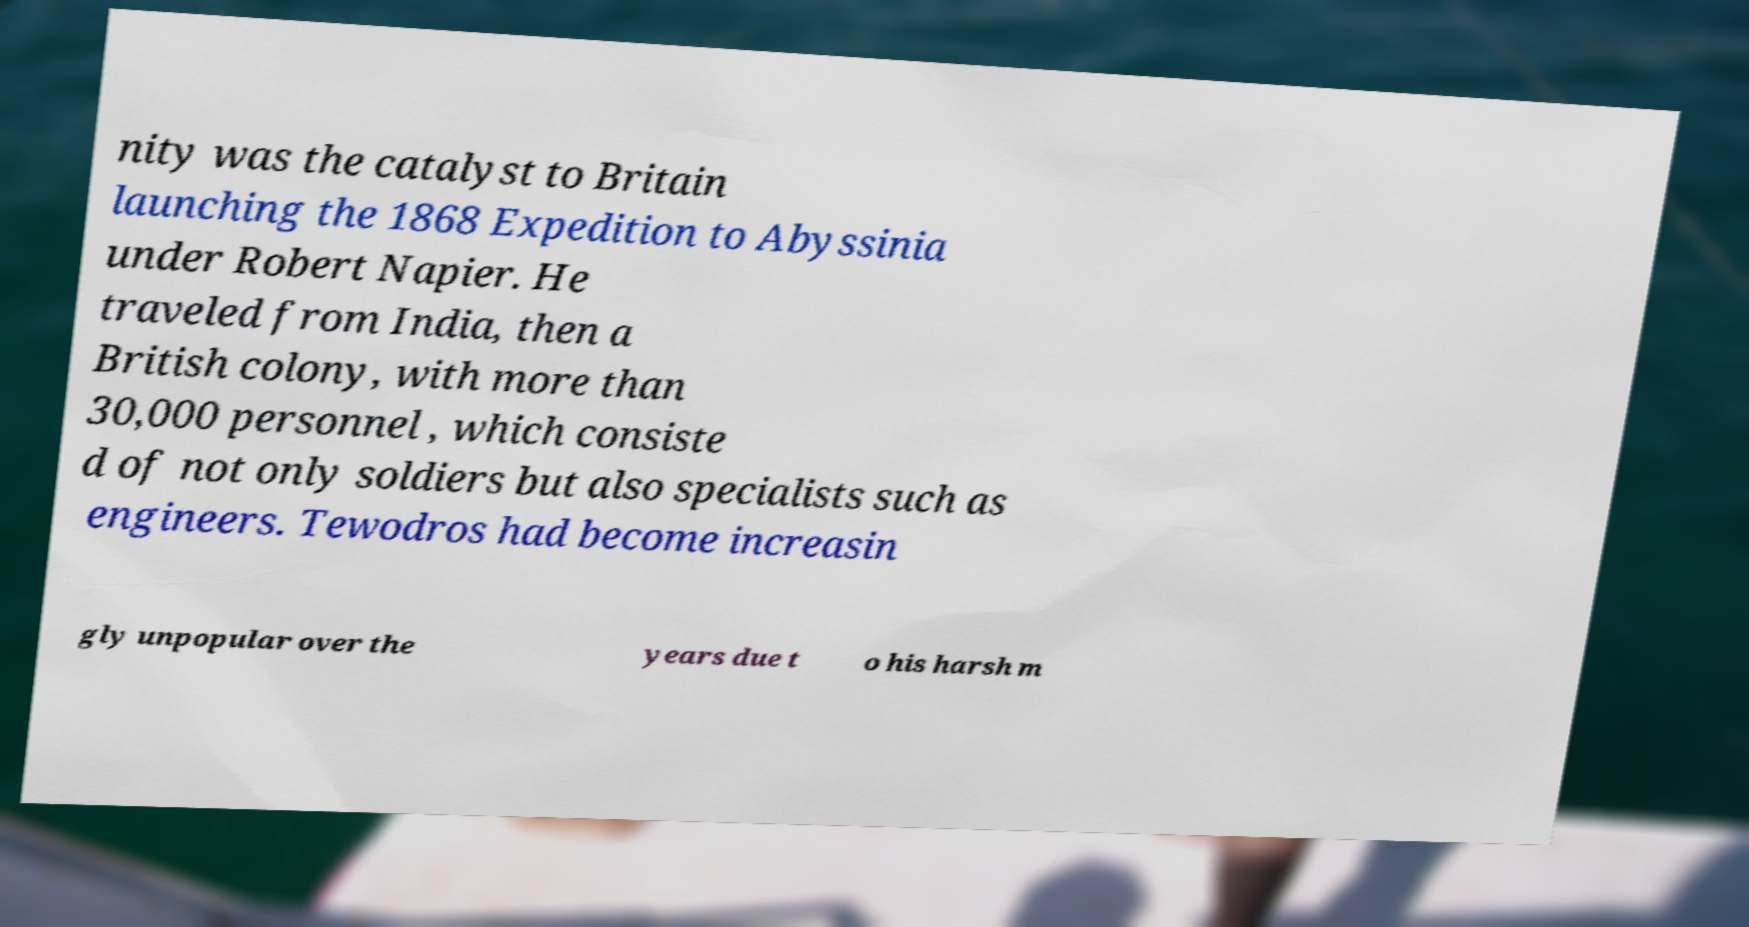Can you read and provide the text displayed in the image?This photo seems to have some interesting text. Can you extract and type it out for me? nity was the catalyst to Britain launching the 1868 Expedition to Abyssinia under Robert Napier. He traveled from India, then a British colony, with more than 30,000 personnel , which consiste d of not only soldiers but also specialists such as engineers. Tewodros had become increasin gly unpopular over the years due t o his harsh m 